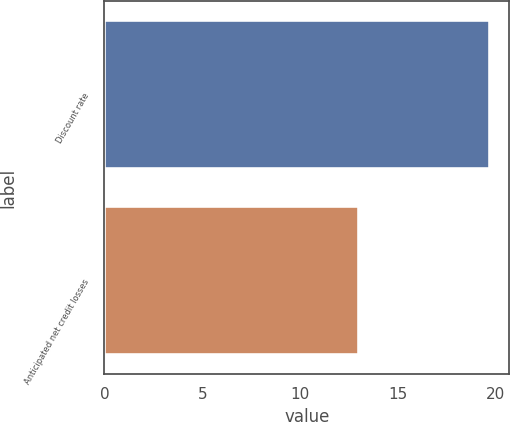Convert chart to OTSL. <chart><loc_0><loc_0><loc_500><loc_500><bar_chart><fcel>Discount rate<fcel>Anticipated net credit losses<nl><fcel>19.7<fcel>13<nl></chart> 